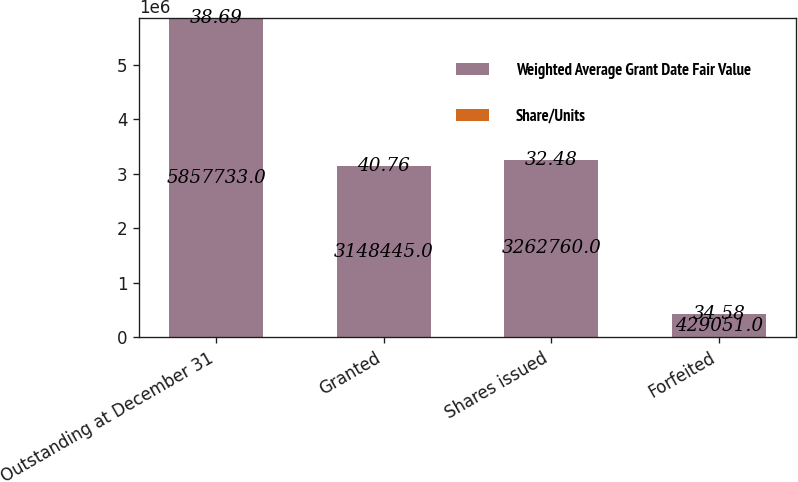<chart> <loc_0><loc_0><loc_500><loc_500><stacked_bar_chart><ecel><fcel>Outstanding at December 31<fcel>Granted<fcel>Shares issued<fcel>Forfeited<nl><fcel>Weighted Average Grant Date Fair Value<fcel>5.85773e+06<fcel>3.14844e+06<fcel>3.26276e+06<fcel>429051<nl><fcel>Share/Units<fcel>38.69<fcel>40.76<fcel>32.48<fcel>34.58<nl></chart> 